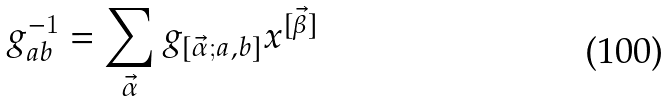<formula> <loc_0><loc_0><loc_500><loc_500>g ^ { - 1 } _ { a b } = \sum _ { \vec { \alpha } } g _ { [ \vec { \alpha } ; a , b ] } x ^ { [ \vec { \beta } ] }</formula> 